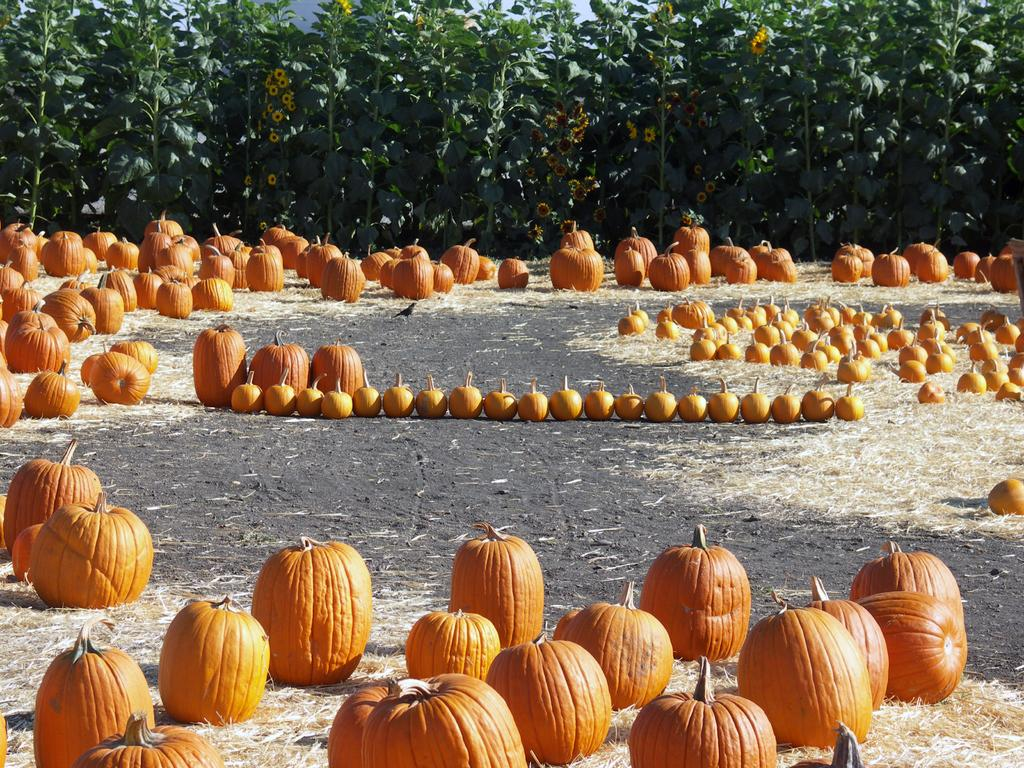What objects are on the ground in the image? There are pumpkins on the ground in the image. What type of vegetation is on the ground? There is grass on the ground in the image. How are the pumpkins and grass distributed in the image? The pumpkins and grass are in random places in the image. What can be seen in the background of the image? There are sunflower plants with flowers in the background, and the sky is visible. What type of wire is being used to hold the sugar in the image? There is no wire or sugar present in the image; it features pumpkins and grass on the ground with sunflower plants and the sky in the background. 